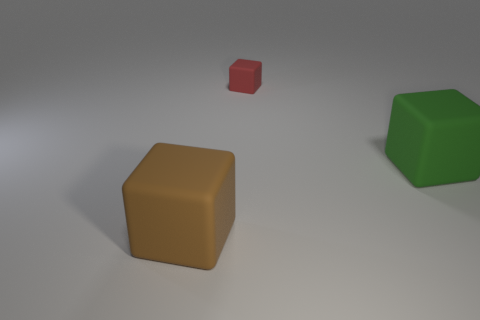Is there any other thing that has the same size as the red rubber block?
Keep it short and to the point. No. There is a block that is behind the green rubber cube that is to the right of the red thing; what is its size?
Make the answer very short. Small. Are there any other things that have the same material as the green object?
Make the answer very short. Yes. There is a block that is in front of the large block that is on the right side of the big matte object that is left of the red matte cube; what color is it?
Offer a terse response. Brown. Is the number of small red objects that are behind the red rubber thing less than the number of things?
Give a very brief answer. Yes. What number of red blocks are there?
Provide a succinct answer. 1. There is a large green matte object; does it have the same shape as the tiny object on the right side of the brown matte thing?
Provide a short and direct response. Yes. Is the number of brown cubes in front of the brown rubber cube less than the number of large rubber things that are in front of the green rubber block?
Offer a very short reply. Yes. Do the small object and the large green rubber object have the same shape?
Ensure brevity in your answer.  Yes. What is the size of the green matte cube?
Ensure brevity in your answer.  Large. 